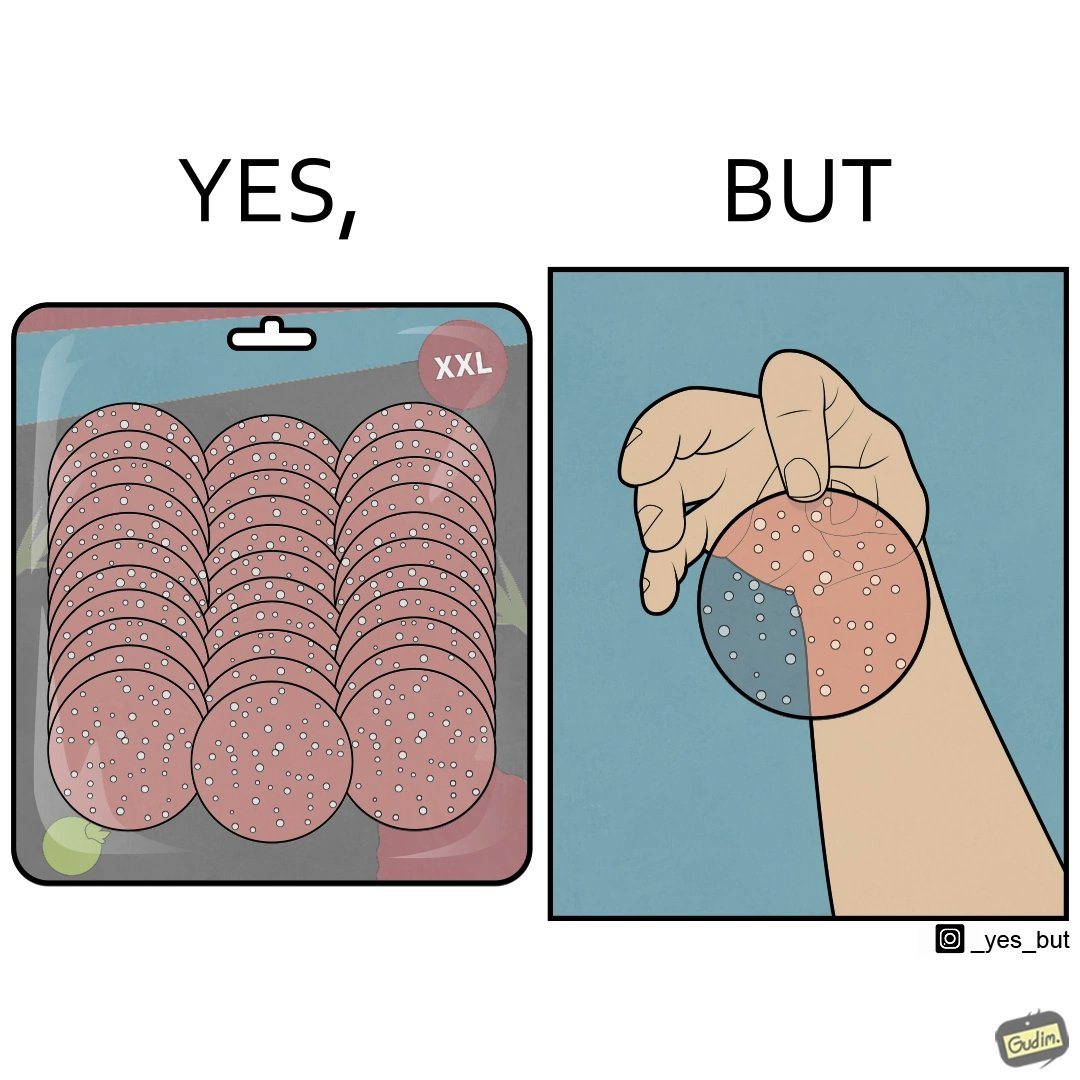Compare the left and right sides of this image. In the left part of the image: A XXL size bag of sliced pepperoni In the right part of the image: A person holding a slice of pepperoni which is so thin that the hand is through it. 